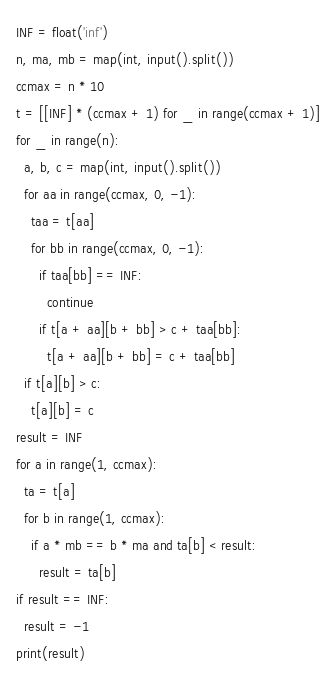<code> <loc_0><loc_0><loc_500><loc_500><_Python_>INF = float('inf')
n, ma, mb = map(int, input().split())
ccmax = n * 10
t = [[INF] * (ccmax + 1) for _ in range(ccmax + 1)]
for _ in range(n):
  a, b, c = map(int, input().split())
  for aa in range(ccmax, 0, -1):
    taa = t[aa]
    for bb in range(ccmax, 0, -1):
      if taa[bb] == INF:
        continue
      if t[a + aa][b + bb] > c + taa[bb]:
        t[a + aa][b + bb] = c + taa[bb]
  if t[a][b] > c:
    t[a][b] = c
result = INF
for a in range(1, ccmax):
  ta = t[a]
  for b in range(1, ccmax):
    if a * mb == b * ma and ta[b] < result:
      result = ta[b]
if result == INF:
  result = -1
print(result)
</code> 